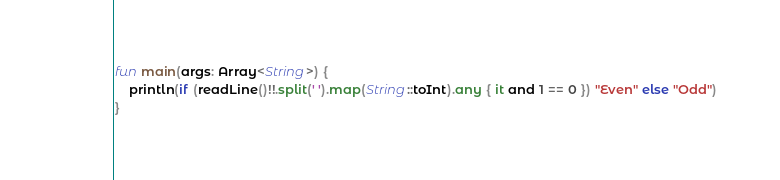<code> <loc_0><loc_0><loc_500><loc_500><_Kotlin_>fun main(args: Array<String>) {
    println(if (readLine()!!.split(' ').map(String::toInt).any { it and 1 == 0 }) "Even" else "Odd")
}
</code> 